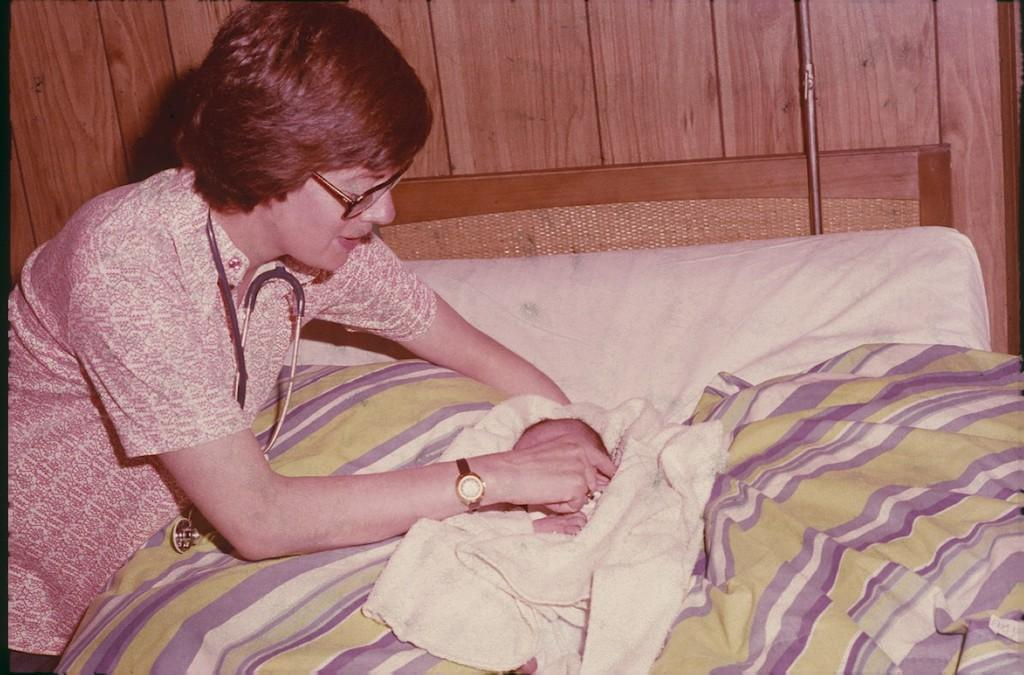Who is present in the image? There is a woman in the image. What is the woman doing in the image? The woman is leaning on the bed. What is covering the bed? There is a bed sheet on the bed. What type of wall can be seen in the background of the image? There is a wooden wall in the background of the image. What type of dress is the woman wearing in the image? The provided facts do not mention the type of dress the woman is wearing, so we cannot determine that from the image. 